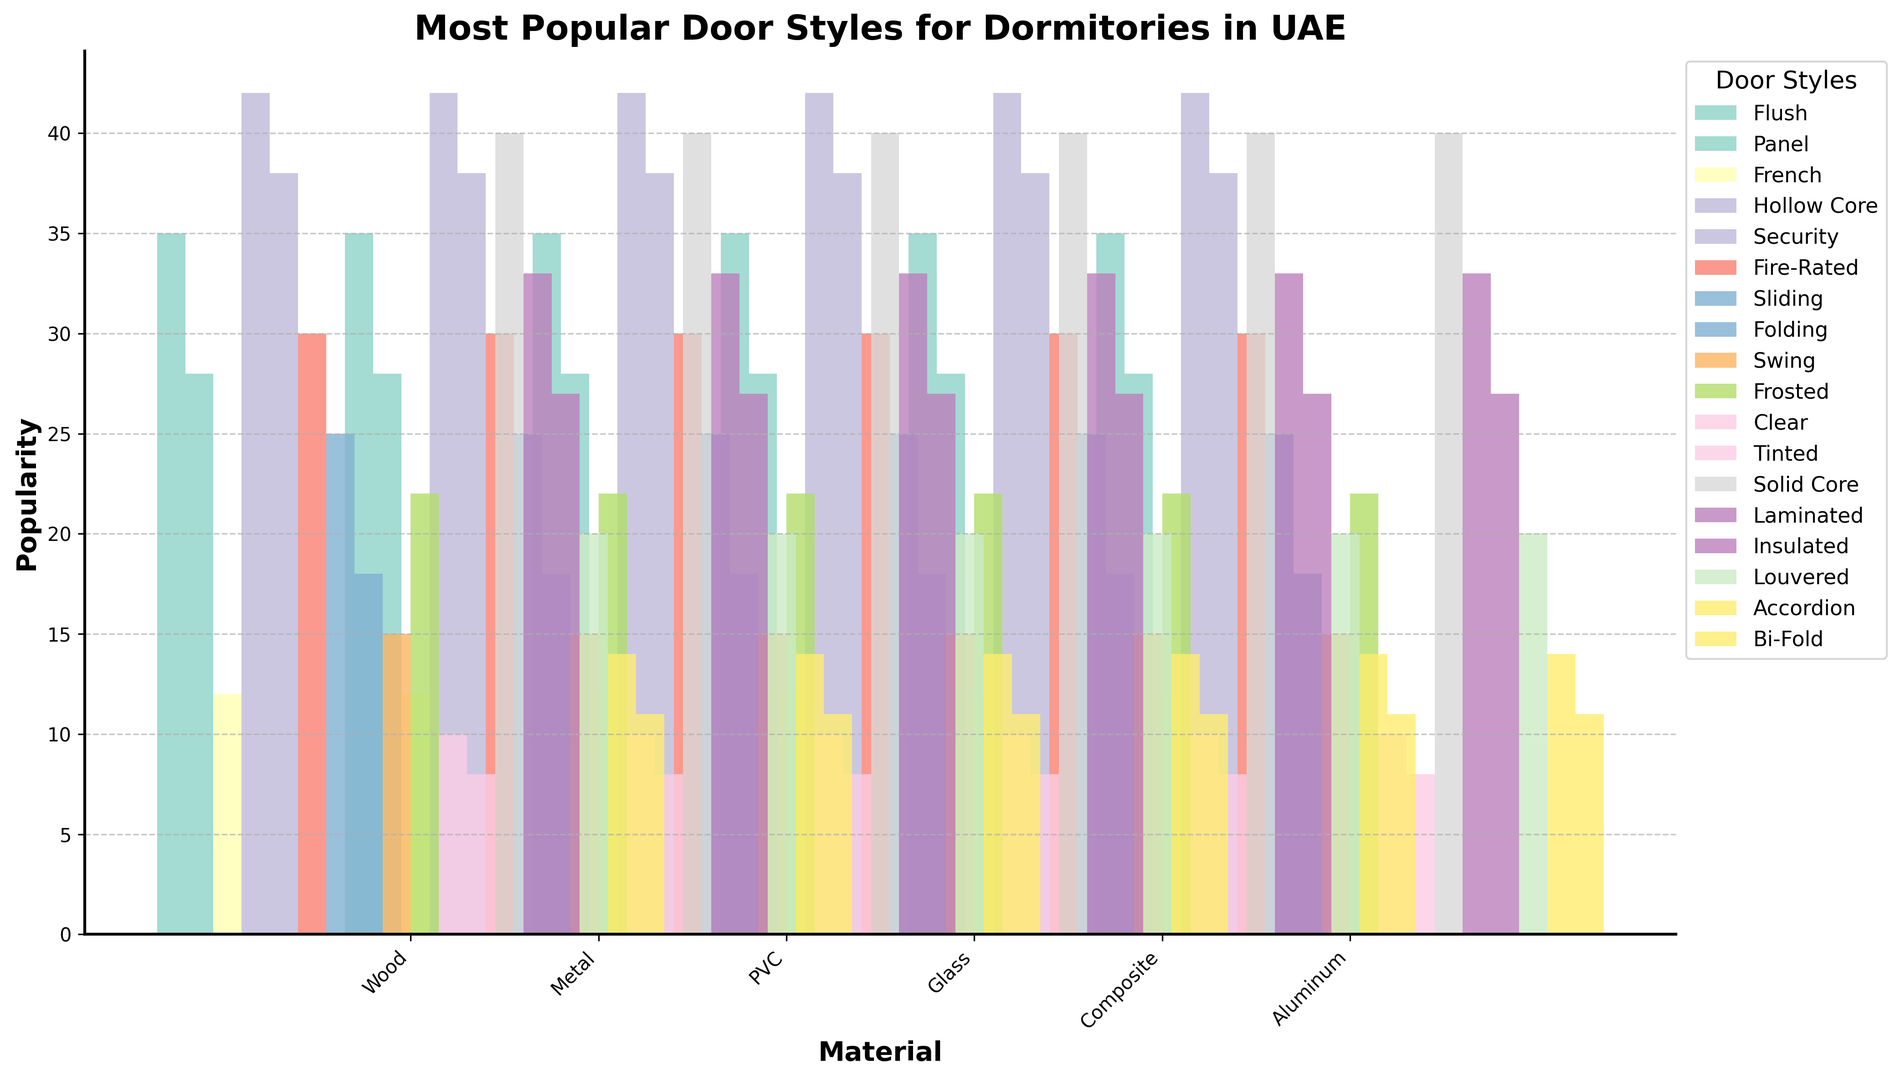Which material has the most popular style overall? To determine which material has the most popular style overall, we compare the highest popularity values across all materials. Metal with Hollow Core doors has the highest popularity at 42.
Answer: Metal What is the least popular door style for composite material? To find the least popular door style for composite material, we identify the styles under Composite (Solid Core, Laminated, Insulated) and compare their popularity values (40, 33, 27). The least popular is Insulated at 27.
Answer: Insulated Which door style has the highest popularity for PVC material? To see which door style is most popular for PVC, check the styles under PVC (Sliding, Folding, Swing) and their respective popularities (25, 18, 15). The most popular style is Sliding at 25.
Answer: Sliding How many styles have a popularity greater than 30 regardless of the material? We look for styles across all materials with popularity values exceeding 30. The styles are Hollow Core (42), Security (38), Solid Core (40), Laminated (33), Flush (35). There are 5 such styles.
Answer: 5 Compare the popularity of French style doors across different materials. French style doors only appear under Wood in the dataset, with a popularity value of 12. There is no need for comparison with other materials.
Answer: 12 Which material has the most variety in door styles? We count the number of unique styles for each material. Wood has 3 styles, Metal has 3, PVC has 3, Glass has 3, Composite has 3, and Aluminum has 3. All materials have an equal variety of 3 styles.
Answer: Wood, Metal, PVC, Glass, Composite, Aluminum What is the total popularity for Glass material styles? Sum the popularity values for all Glass styles (Frosted, Clear, Tinted). This is 22 + 10 + 8 = 40.
Answer: 40 Compare the popularity of the Flush style for Wood to the Fire-Rated style for Metal. Which is more popular? Identify the popularity values of Flush in Wood (35) and Fire-Rated in Metal (30). Flush style is more popular.
Answer: Flush What is the average popularity of styles for Aluminum material? Calculate the average popularity of styles under Aluminum (Louvered, Accordion, Bi-Fold) as follows: (20 + 14 + 11) / 3 = 45 / 3 = 15.
Answer: 15 Which door style across all materials has the highest popularity, and what is its value? The door style with the highest popularity across all materials can be identified by comparing all values. Metal's Hollow Core style has the highest popularity at 42.
Answer: Hollow Core, 42 